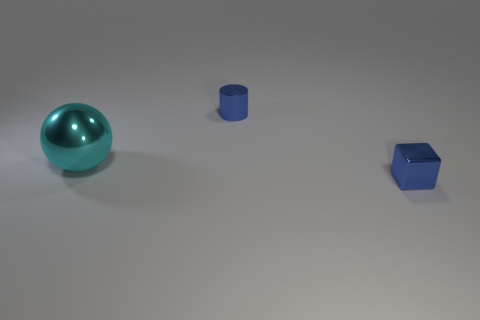What shape is the small blue metal thing on the right side of the small metal cylinder?
Your response must be concise. Cube. There is a blue thing that is the same material as the tiny blue cube; what is its shape?
Offer a very short reply. Cylinder. How many shiny objects are small blue cylinders or big things?
Ensure brevity in your answer.  2. There is a blue object to the left of the blue thing that is in front of the cyan shiny ball; what number of small cubes are on the right side of it?
Keep it short and to the point. 1. There is a metallic object in front of the big cyan metallic ball; is its size the same as the metallic object that is behind the cyan metallic object?
Offer a terse response. Yes. What number of tiny things are either metal cubes or yellow metallic balls?
Your answer should be compact. 1. What material is the thing that is right of the large cyan sphere and in front of the tiny metallic cylinder?
Offer a terse response. Metal. There is a cube; is its color the same as the small thing left of the small blue block?
Ensure brevity in your answer.  Yes. Is there a small blue object made of the same material as the large thing?
Give a very brief answer. Yes. How many red cubes are there?
Provide a succinct answer. 0. 